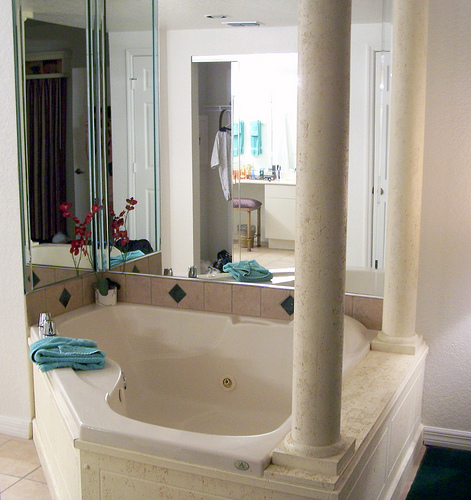<image>What color is the water in the bathtub? There is no water in the bathtub. What color is the water in the bathtub? There is no water in the bathtub. 